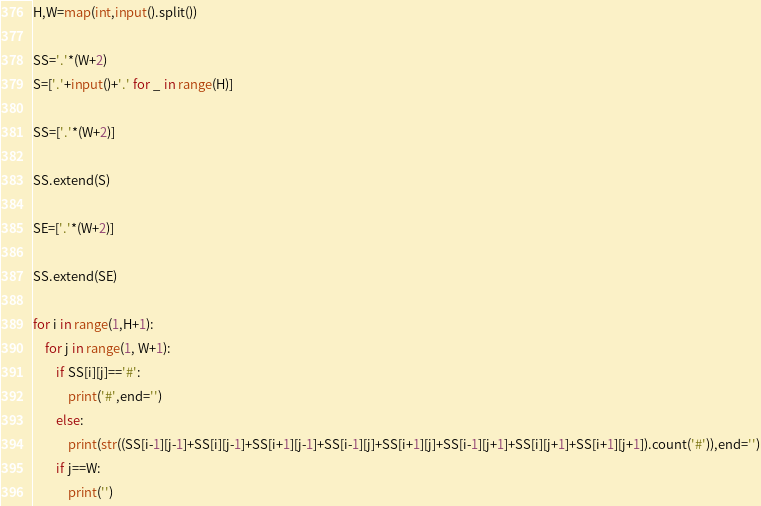Convert code to text. <code><loc_0><loc_0><loc_500><loc_500><_Python_>H,W=map(int,input().split())

SS='.'*(W+2)
S=['.'+input()+'.' for _ in range(H)]

SS=['.'*(W+2)]

SS.extend(S)

SE=['.'*(W+2)]

SS.extend(SE)

for i in range(1,H+1):
    for j in range(1, W+1):
        if SS[i][j]=='#':
            print('#',end='')
        else:   
            print(str((SS[i-1][j-1]+SS[i][j-1]+SS[i+1][j-1]+SS[i-1][j]+SS[i+1][j]+SS[i-1][j+1]+SS[i][j+1]+SS[i+1][j+1]).count('#')),end='')
        if j==W:
            print('')</code> 